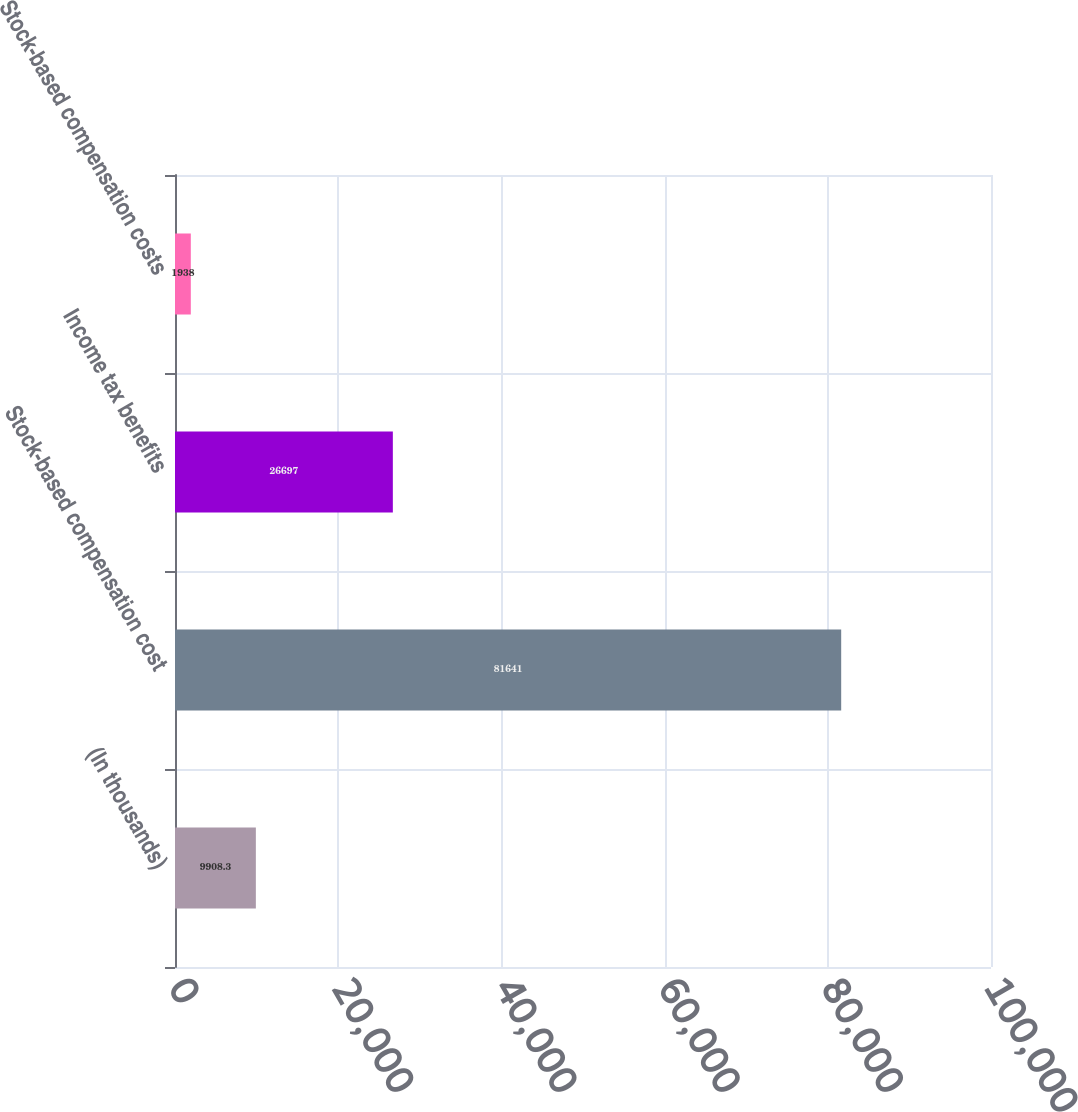Convert chart to OTSL. <chart><loc_0><loc_0><loc_500><loc_500><bar_chart><fcel>(In thousands)<fcel>Stock-based compensation cost<fcel>Income tax benefits<fcel>Stock-based compensation costs<nl><fcel>9908.3<fcel>81641<fcel>26697<fcel>1938<nl></chart> 